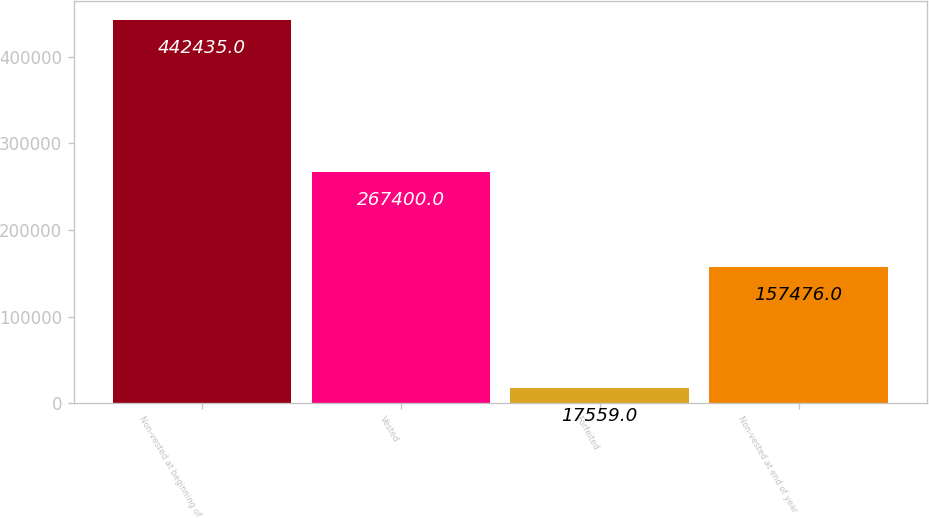Convert chart. <chart><loc_0><loc_0><loc_500><loc_500><bar_chart><fcel>Non-vested at beginning of<fcel>Vested<fcel>Forfeited<fcel>Non-vested at end of year<nl><fcel>442435<fcel>267400<fcel>17559<fcel>157476<nl></chart> 